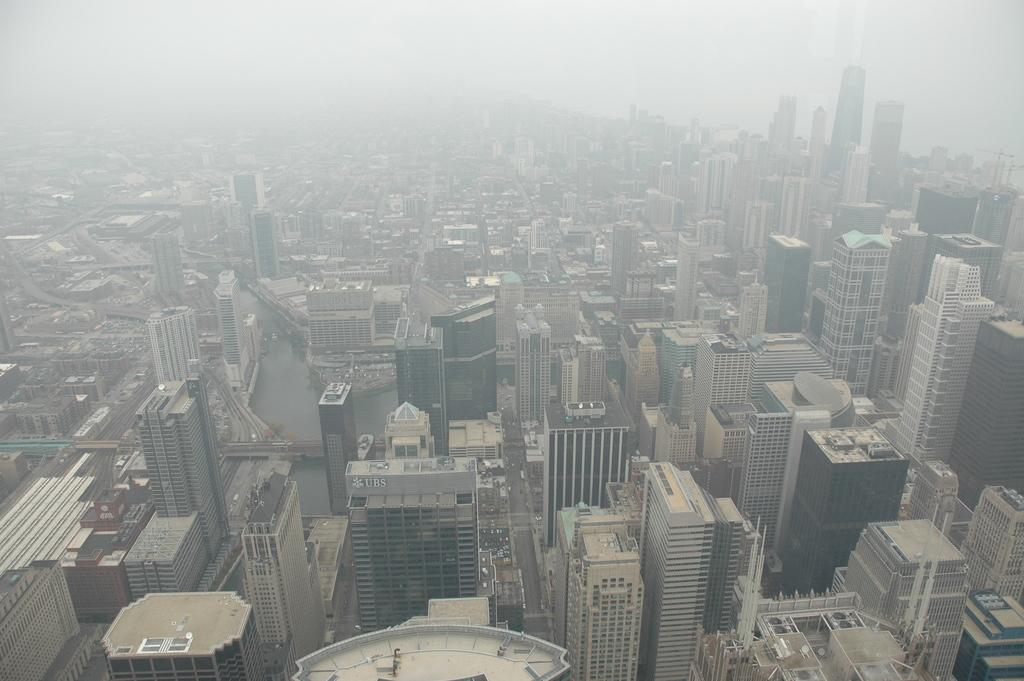What type of view is shown in the image? The image is an aerial view. What structures can be seen from this perspective? There are buildings visible in the image. What else can be seen in the image besides buildings? There are roads and vehicles visible in the image. What is visible at the top of the image? The sky is visible at the top of the image. What type of wool can be seen on the coast in the image? There is no wool or coast present in the image; it shows an aerial view of buildings, roads, vehicles, and the sky. How many rabbits can be seen in the image? There are no rabbits present in the image. 